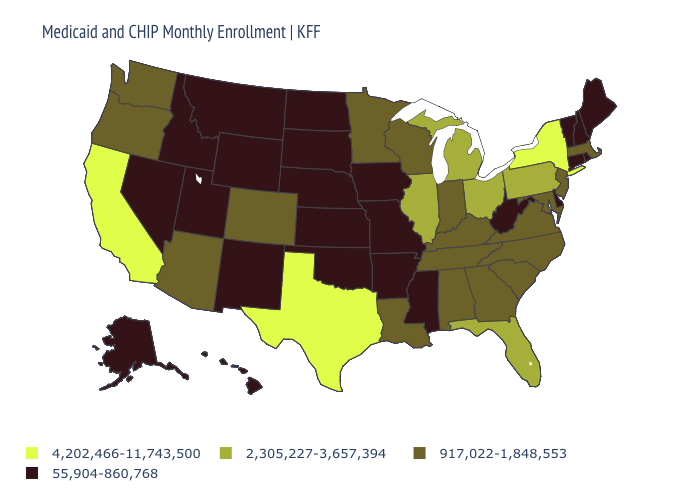What is the value of Arkansas?
Keep it brief. 55,904-860,768. Is the legend a continuous bar?
Concise answer only. No. Name the states that have a value in the range 917,022-1,848,553?
Write a very short answer. Alabama, Arizona, Colorado, Georgia, Indiana, Kentucky, Louisiana, Maryland, Massachusetts, Minnesota, New Jersey, North Carolina, Oregon, South Carolina, Tennessee, Virginia, Washington, Wisconsin. What is the value of California?
Short answer required. 4,202,466-11,743,500. Does the first symbol in the legend represent the smallest category?
Give a very brief answer. No. What is the value of Georgia?
Short answer required. 917,022-1,848,553. What is the highest value in the Northeast ?
Keep it brief. 4,202,466-11,743,500. Which states have the lowest value in the USA?
Answer briefly. Alaska, Arkansas, Connecticut, Delaware, Hawaii, Idaho, Iowa, Kansas, Maine, Mississippi, Missouri, Montana, Nebraska, Nevada, New Hampshire, New Mexico, North Dakota, Oklahoma, Rhode Island, South Dakota, Utah, Vermont, West Virginia, Wyoming. Does Kansas have the highest value in the USA?
Concise answer only. No. What is the value of Kentucky?
Be succinct. 917,022-1,848,553. Does the first symbol in the legend represent the smallest category?
Give a very brief answer. No. Name the states that have a value in the range 4,202,466-11,743,500?
Answer briefly. California, New York, Texas. Name the states that have a value in the range 2,305,227-3,657,394?
Short answer required. Florida, Illinois, Michigan, Ohio, Pennsylvania. What is the value of Virginia?
Quick response, please. 917,022-1,848,553. Among the states that border Idaho , which have the lowest value?
Be succinct. Montana, Nevada, Utah, Wyoming. 